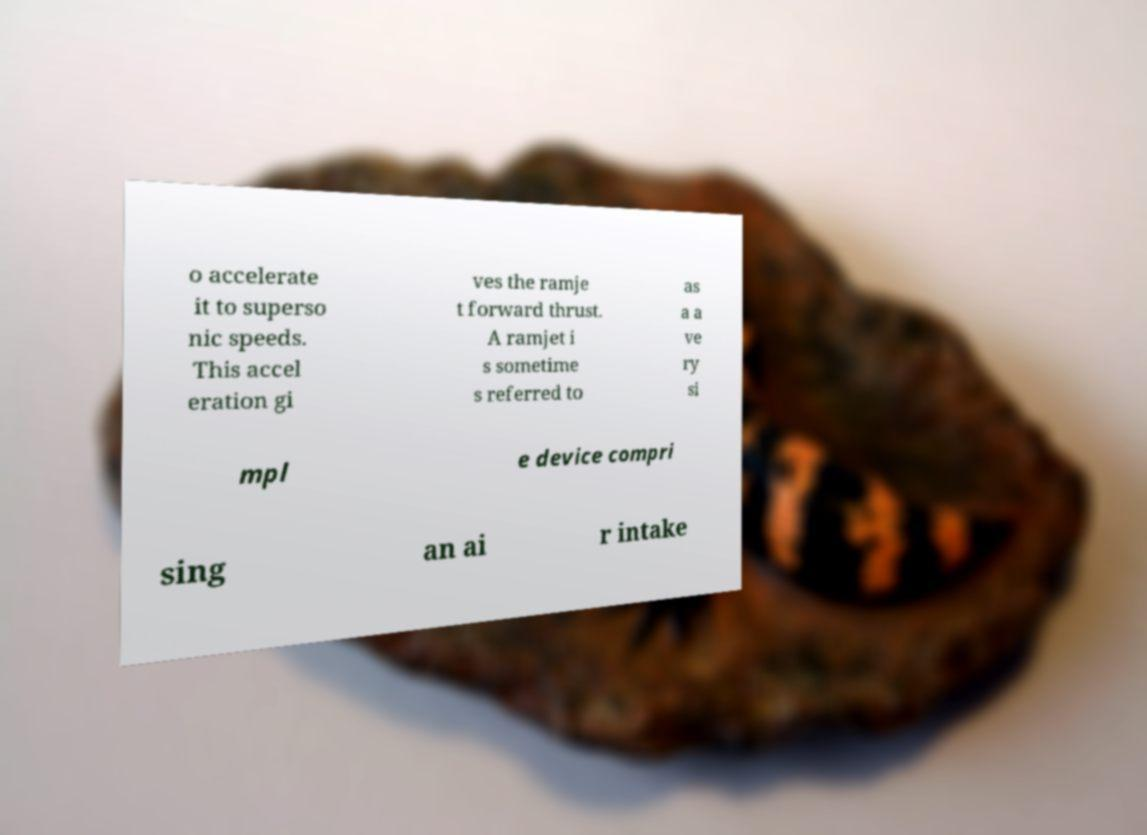For documentation purposes, I need the text within this image transcribed. Could you provide that? o accelerate it to superso nic speeds. This accel eration gi ves the ramje t forward thrust. A ramjet i s sometime s referred to as a a ve ry si mpl e device compri sing an ai r intake 